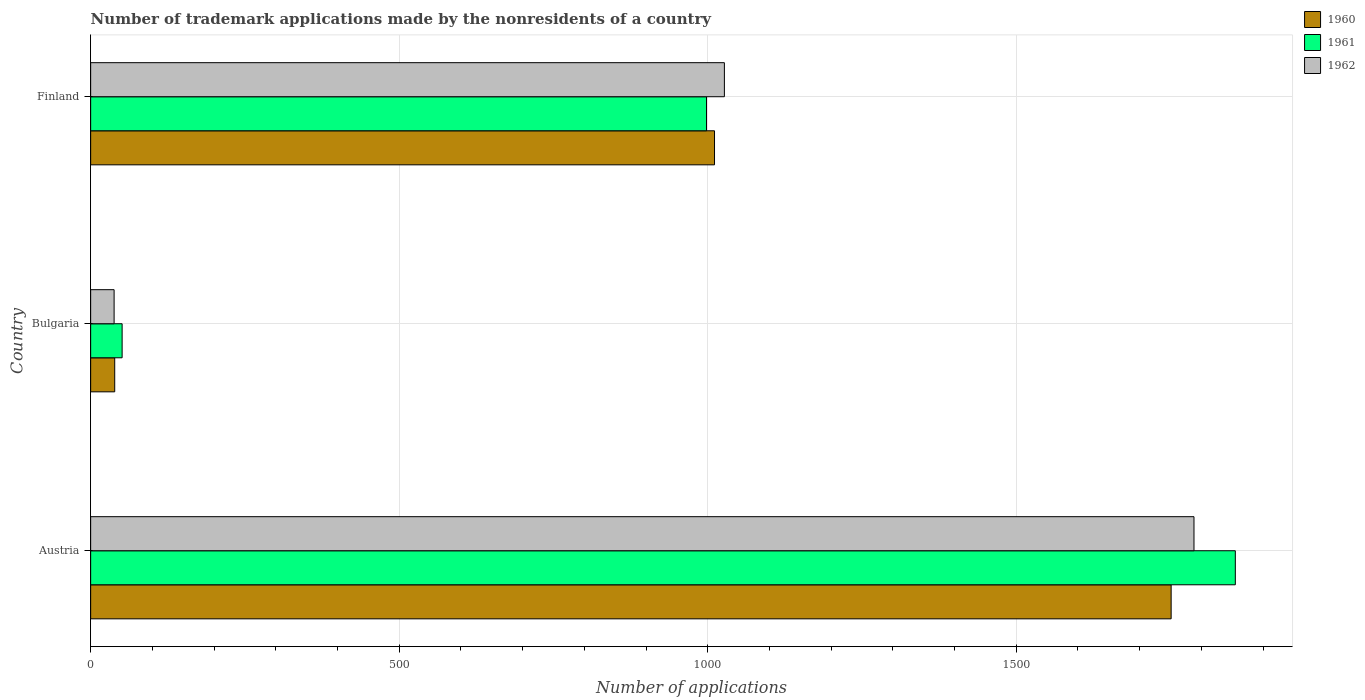How many different coloured bars are there?
Provide a short and direct response. 3. Are the number of bars per tick equal to the number of legend labels?
Ensure brevity in your answer.  Yes. How many bars are there on the 3rd tick from the bottom?
Offer a very short reply. 3. What is the label of the 2nd group of bars from the top?
Offer a very short reply. Bulgaria. In how many cases, is the number of bars for a given country not equal to the number of legend labels?
Ensure brevity in your answer.  0. What is the number of trademark applications made by the nonresidents in 1960 in Finland?
Your answer should be compact. 1011. Across all countries, what is the maximum number of trademark applications made by the nonresidents in 1962?
Make the answer very short. 1788. Across all countries, what is the minimum number of trademark applications made by the nonresidents in 1962?
Give a very brief answer. 38. What is the total number of trademark applications made by the nonresidents in 1961 in the graph?
Give a very brief answer. 2904. What is the difference between the number of trademark applications made by the nonresidents in 1962 in Bulgaria and that in Finland?
Provide a succinct answer. -989. What is the difference between the number of trademark applications made by the nonresidents in 1961 in Bulgaria and the number of trademark applications made by the nonresidents in 1962 in Austria?
Give a very brief answer. -1737. What is the average number of trademark applications made by the nonresidents in 1962 per country?
Make the answer very short. 951. What is the difference between the number of trademark applications made by the nonresidents in 1961 and number of trademark applications made by the nonresidents in 1962 in Austria?
Keep it short and to the point. 67. In how many countries, is the number of trademark applications made by the nonresidents in 1962 greater than 1800 ?
Give a very brief answer. 0. What is the ratio of the number of trademark applications made by the nonresidents in 1962 in Austria to that in Bulgaria?
Keep it short and to the point. 47.05. Is the difference between the number of trademark applications made by the nonresidents in 1961 in Bulgaria and Finland greater than the difference between the number of trademark applications made by the nonresidents in 1962 in Bulgaria and Finland?
Your answer should be compact. Yes. What is the difference between the highest and the second highest number of trademark applications made by the nonresidents in 1962?
Provide a short and direct response. 761. What is the difference between the highest and the lowest number of trademark applications made by the nonresidents in 1962?
Your response must be concise. 1750. Is the sum of the number of trademark applications made by the nonresidents in 1961 in Austria and Bulgaria greater than the maximum number of trademark applications made by the nonresidents in 1962 across all countries?
Your response must be concise. Yes. What does the 3rd bar from the top in Bulgaria represents?
Provide a succinct answer. 1960. What does the 1st bar from the bottom in Austria represents?
Ensure brevity in your answer.  1960. Are all the bars in the graph horizontal?
Your answer should be very brief. Yes. How many countries are there in the graph?
Provide a succinct answer. 3. What is the difference between two consecutive major ticks on the X-axis?
Ensure brevity in your answer.  500. Does the graph contain grids?
Your answer should be very brief. Yes. What is the title of the graph?
Offer a terse response. Number of trademark applications made by the nonresidents of a country. Does "1986" appear as one of the legend labels in the graph?
Provide a short and direct response. No. What is the label or title of the X-axis?
Keep it short and to the point. Number of applications. What is the label or title of the Y-axis?
Your response must be concise. Country. What is the Number of applications of 1960 in Austria?
Keep it short and to the point. 1751. What is the Number of applications of 1961 in Austria?
Provide a short and direct response. 1855. What is the Number of applications in 1962 in Austria?
Provide a succinct answer. 1788. What is the Number of applications in 1960 in Bulgaria?
Offer a terse response. 39. What is the Number of applications in 1962 in Bulgaria?
Give a very brief answer. 38. What is the Number of applications in 1960 in Finland?
Provide a short and direct response. 1011. What is the Number of applications of 1961 in Finland?
Ensure brevity in your answer.  998. What is the Number of applications of 1962 in Finland?
Provide a succinct answer. 1027. Across all countries, what is the maximum Number of applications of 1960?
Provide a succinct answer. 1751. Across all countries, what is the maximum Number of applications of 1961?
Provide a short and direct response. 1855. Across all countries, what is the maximum Number of applications of 1962?
Offer a very short reply. 1788. Across all countries, what is the minimum Number of applications in 1960?
Keep it short and to the point. 39. What is the total Number of applications of 1960 in the graph?
Give a very brief answer. 2801. What is the total Number of applications of 1961 in the graph?
Ensure brevity in your answer.  2904. What is the total Number of applications of 1962 in the graph?
Keep it short and to the point. 2853. What is the difference between the Number of applications of 1960 in Austria and that in Bulgaria?
Make the answer very short. 1712. What is the difference between the Number of applications in 1961 in Austria and that in Bulgaria?
Your answer should be compact. 1804. What is the difference between the Number of applications of 1962 in Austria and that in Bulgaria?
Your answer should be compact. 1750. What is the difference between the Number of applications of 1960 in Austria and that in Finland?
Keep it short and to the point. 740. What is the difference between the Number of applications in 1961 in Austria and that in Finland?
Offer a very short reply. 857. What is the difference between the Number of applications in 1962 in Austria and that in Finland?
Provide a short and direct response. 761. What is the difference between the Number of applications in 1960 in Bulgaria and that in Finland?
Make the answer very short. -972. What is the difference between the Number of applications of 1961 in Bulgaria and that in Finland?
Provide a succinct answer. -947. What is the difference between the Number of applications of 1962 in Bulgaria and that in Finland?
Provide a succinct answer. -989. What is the difference between the Number of applications in 1960 in Austria and the Number of applications in 1961 in Bulgaria?
Keep it short and to the point. 1700. What is the difference between the Number of applications of 1960 in Austria and the Number of applications of 1962 in Bulgaria?
Offer a very short reply. 1713. What is the difference between the Number of applications of 1961 in Austria and the Number of applications of 1962 in Bulgaria?
Make the answer very short. 1817. What is the difference between the Number of applications in 1960 in Austria and the Number of applications in 1961 in Finland?
Your answer should be compact. 753. What is the difference between the Number of applications of 1960 in Austria and the Number of applications of 1962 in Finland?
Your answer should be very brief. 724. What is the difference between the Number of applications in 1961 in Austria and the Number of applications in 1962 in Finland?
Offer a very short reply. 828. What is the difference between the Number of applications in 1960 in Bulgaria and the Number of applications in 1961 in Finland?
Your response must be concise. -959. What is the difference between the Number of applications in 1960 in Bulgaria and the Number of applications in 1962 in Finland?
Give a very brief answer. -988. What is the difference between the Number of applications of 1961 in Bulgaria and the Number of applications of 1962 in Finland?
Ensure brevity in your answer.  -976. What is the average Number of applications of 1960 per country?
Ensure brevity in your answer.  933.67. What is the average Number of applications of 1961 per country?
Your answer should be compact. 968. What is the average Number of applications of 1962 per country?
Your answer should be very brief. 951. What is the difference between the Number of applications in 1960 and Number of applications in 1961 in Austria?
Offer a terse response. -104. What is the difference between the Number of applications of 1960 and Number of applications of 1962 in Austria?
Keep it short and to the point. -37. What is the difference between the Number of applications of 1961 and Number of applications of 1962 in Bulgaria?
Offer a very short reply. 13. What is the difference between the Number of applications of 1960 and Number of applications of 1961 in Finland?
Keep it short and to the point. 13. What is the ratio of the Number of applications of 1960 in Austria to that in Bulgaria?
Offer a terse response. 44.9. What is the ratio of the Number of applications of 1961 in Austria to that in Bulgaria?
Offer a terse response. 36.37. What is the ratio of the Number of applications of 1962 in Austria to that in Bulgaria?
Your answer should be very brief. 47.05. What is the ratio of the Number of applications of 1960 in Austria to that in Finland?
Ensure brevity in your answer.  1.73. What is the ratio of the Number of applications of 1961 in Austria to that in Finland?
Give a very brief answer. 1.86. What is the ratio of the Number of applications in 1962 in Austria to that in Finland?
Your answer should be compact. 1.74. What is the ratio of the Number of applications of 1960 in Bulgaria to that in Finland?
Your answer should be compact. 0.04. What is the ratio of the Number of applications in 1961 in Bulgaria to that in Finland?
Give a very brief answer. 0.05. What is the ratio of the Number of applications of 1962 in Bulgaria to that in Finland?
Keep it short and to the point. 0.04. What is the difference between the highest and the second highest Number of applications in 1960?
Give a very brief answer. 740. What is the difference between the highest and the second highest Number of applications of 1961?
Give a very brief answer. 857. What is the difference between the highest and the second highest Number of applications of 1962?
Your answer should be compact. 761. What is the difference between the highest and the lowest Number of applications of 1960?
Your answer should be compact. 1712. What is the difference between the highest and the lowest Number of applications of 1961?
Keep it short and to the point. 1804. What is the difference between the highest and the lowest Number of applications of 1962?
Keep it short and to the point. 1750. 